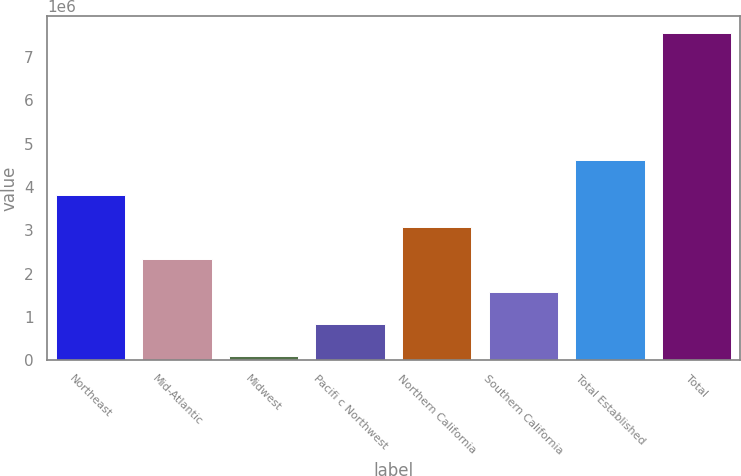Convert chart. <chart><loc_0><loc_0><loc_500><loc_500><bar_chart><fcel>Northeast<fcel>Mid-Atlantic<fcel>Midwest<fcel>Pacifi c Northwest<fcel>Northern California<fcel>Southern California<fcel>Total Established<fcel>Total<nl><fcel>3.82481e+06<fcel>2.33204e+06<fcel>92879<fcel>839265<fcel>3.07842e+06<fcel>1.58565e+06<fcel>4.62374e+06<fcel>7.55674e+06<nl></chart> 